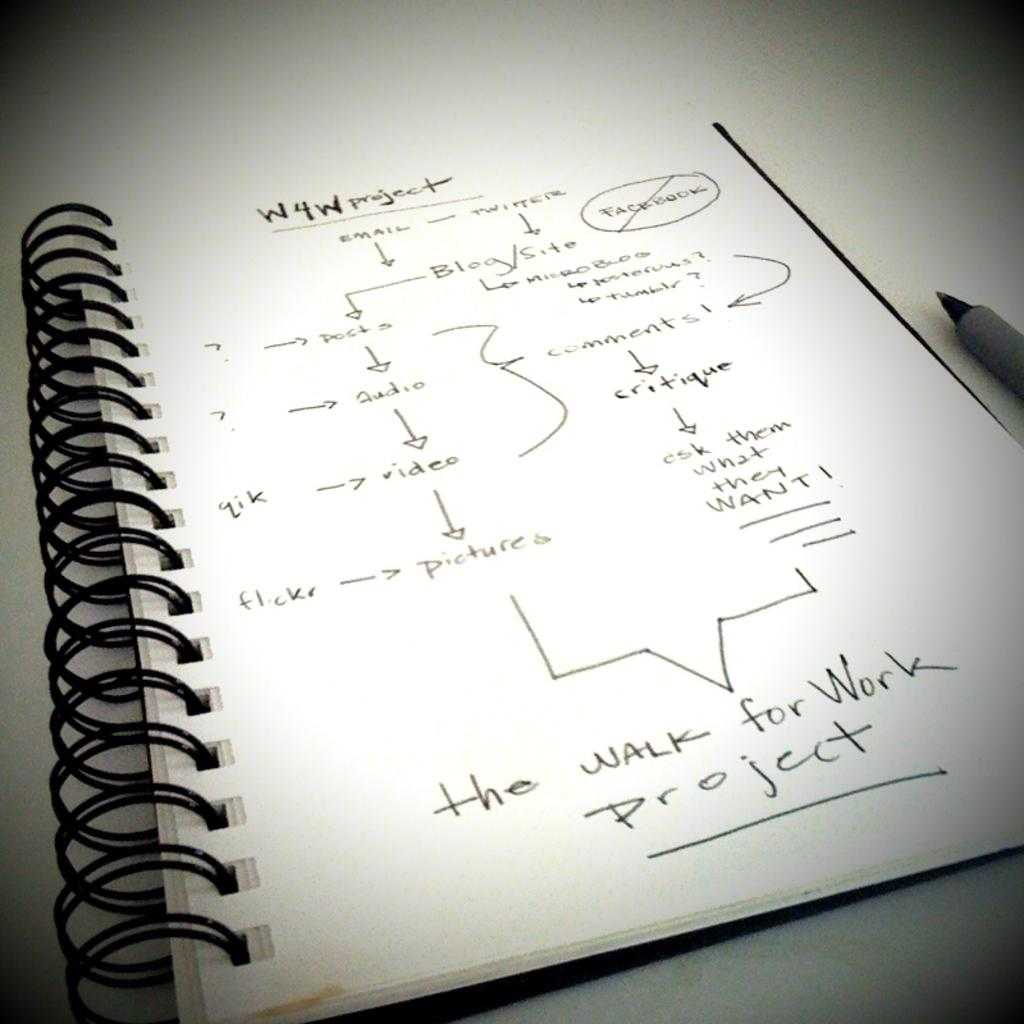Provide a one-sentence caption for the provided image. A notebook with the W4W project details listed on a page. 